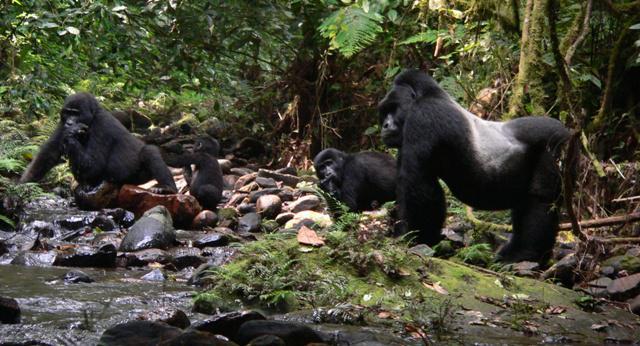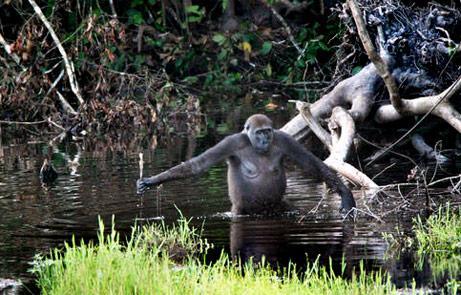The first image is the image on the left, the second image is the image on the right. Considering the images on both sides, is "In one image, one gorilla is walking leftward behind another and reaching an arm out to touch it." valid? Answer yes or no. No. 